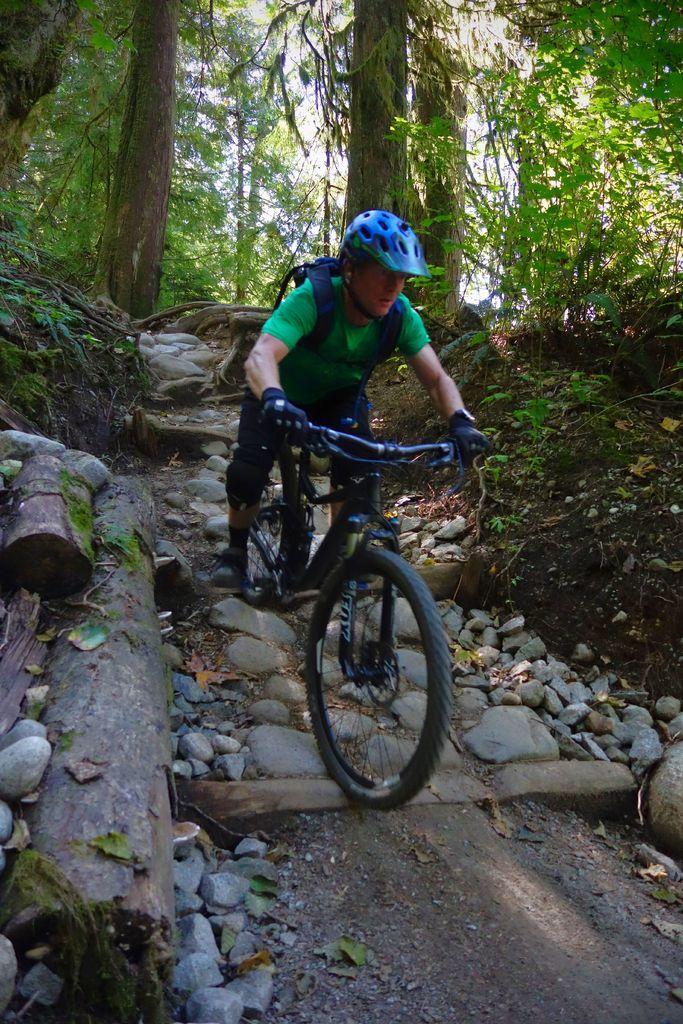Describe this image in one or two sentences. In this image there is a person riding a bicycle in the woods, behind the person there are trees. 